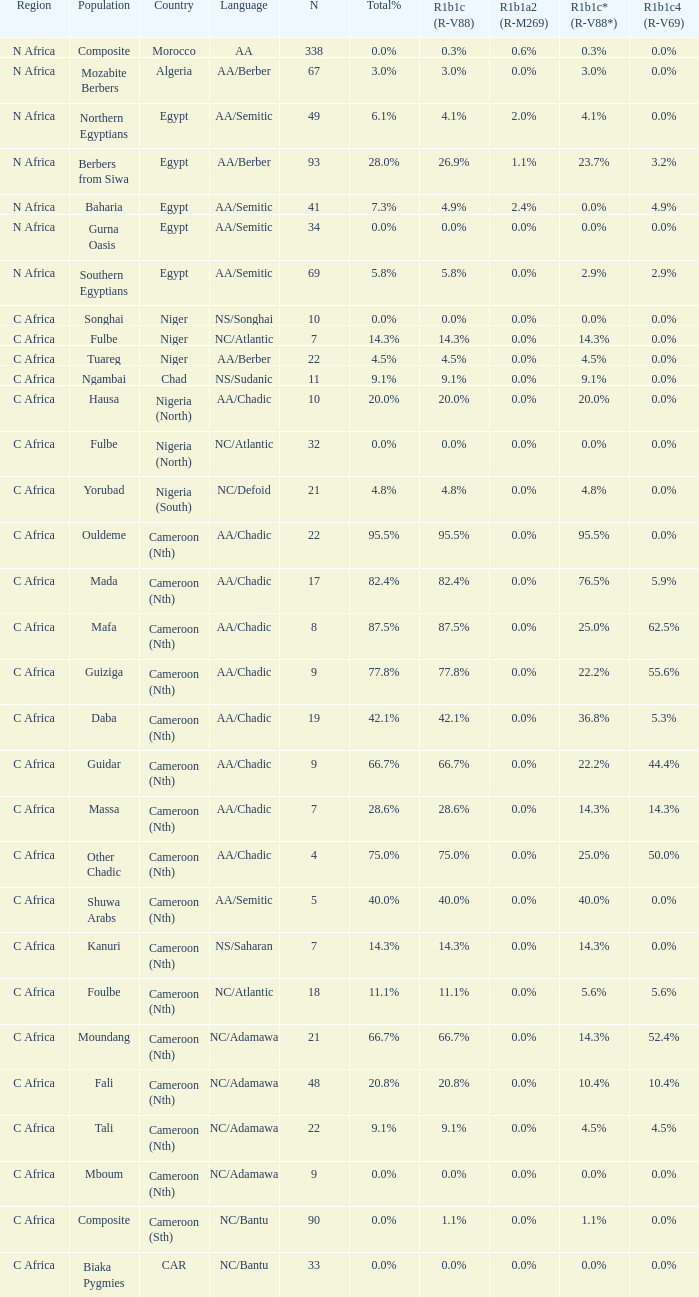6% r1b1c4 (r-v69)? 9.0. 